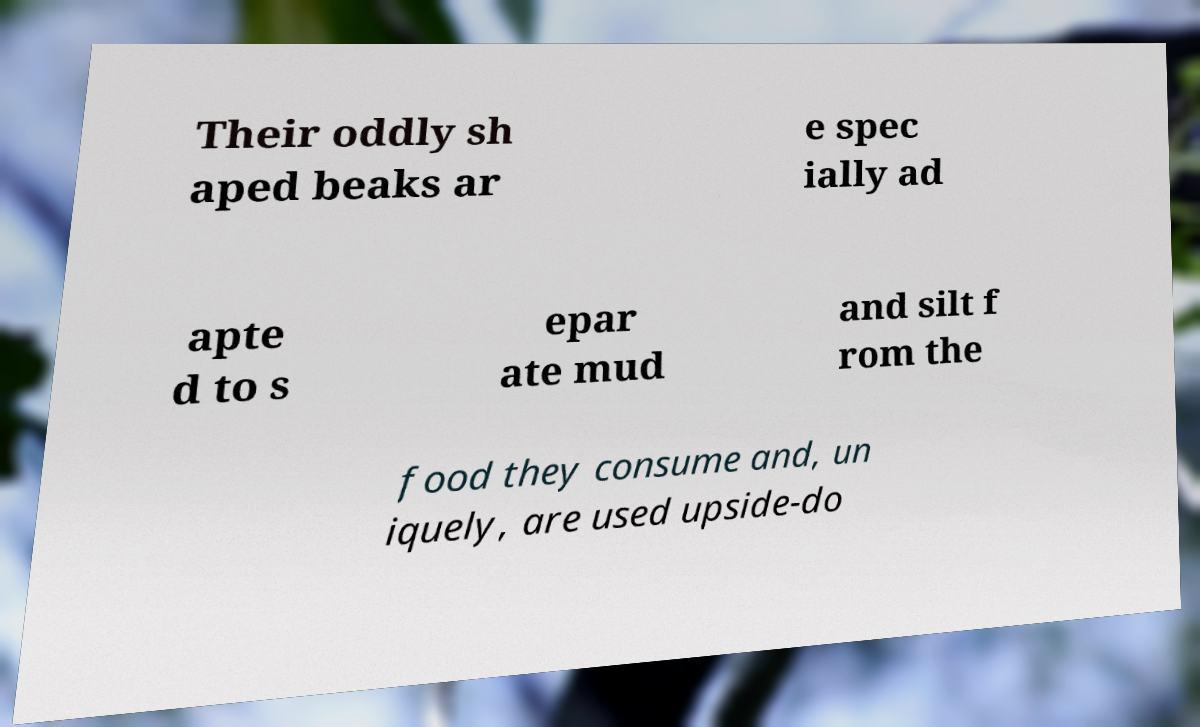Can you read and provide the text displayed in the image?This photo seems to have some interesting text. Can you extract and type it out for me? Their oddly sh aped beaks ar e spec ially ad apte d to s epar ate mud and silt f rom the food they consume and, un iquely, are used upside-do 